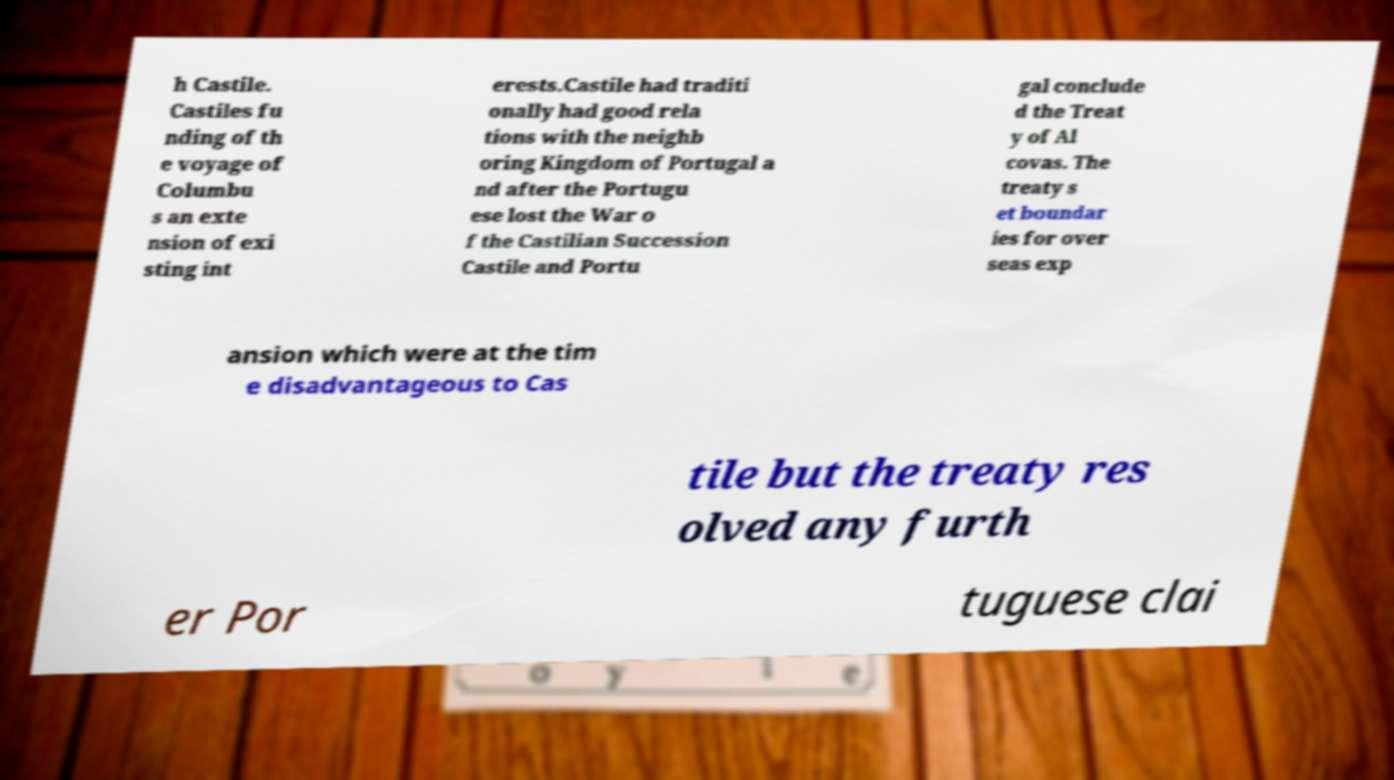There's text embedded in this image that I need extracted. Can you transcribe it verbatim? h Castile. Castiles fu nding of th e voyage of Columbu s an exte nsion of exi sting int erests.Castile had traditi onally had good rela tions with the neighb oring Kingdom of Portugal a nd after the Portugu ese lost the War o f the Castilian Succession Castile and Portu gal conclude d the Treat y of Al covas. The treaty s et boundar ies for over seas exp ansion which were at the tim e disadvantageous to Cas tile but the treaty res olved any furth er Por tuguese clai 